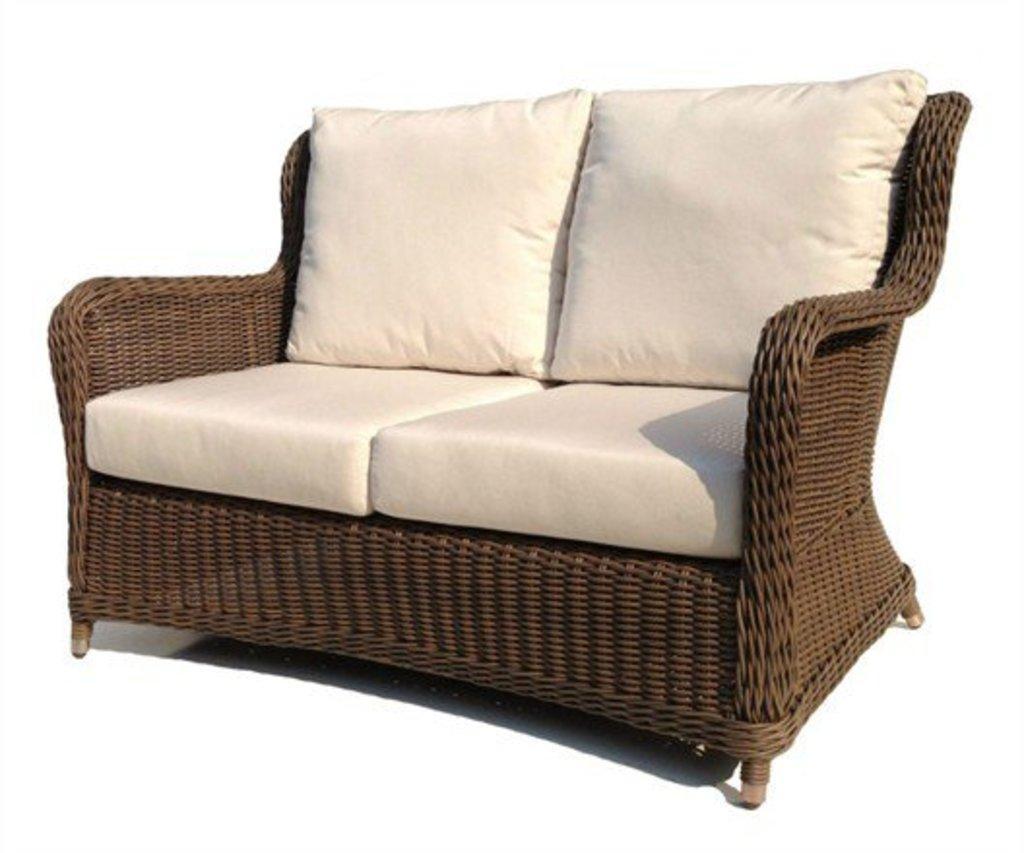Can you describe this image briefly? In this image we can see a sofa set. 